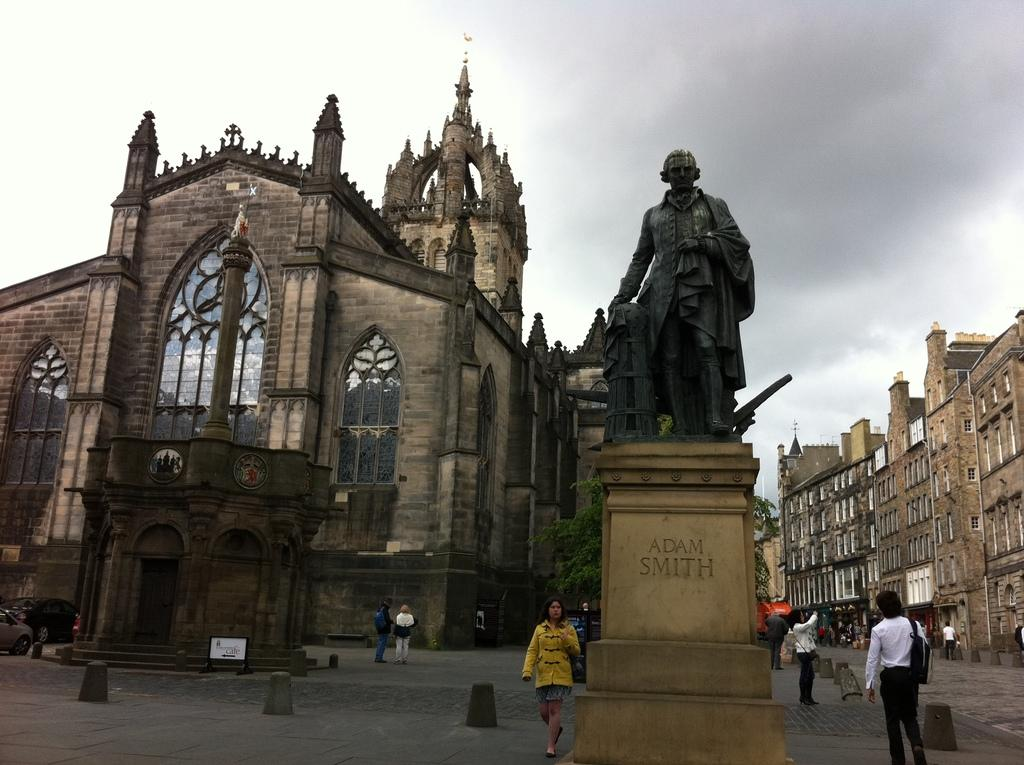What is the main subject in the foreground of the image? There is a sculpture on the road in the foreground of the image. What are the people in the image doing? There are persons moving on the road in the image. What can be seen in the background of the image? There are buildings visible in the image. What is the condition of the sky in the image? The sky contains clouds in the image. How many giants can be seen walking alongside the persons in the image? There are no giants present in the image; only the sculpture, persons, buildings, and clouds can be seen. What type of addition problem can be solved using the numbers of buildings and persons in the image? There is no information provided about the number of buildings or persons in the image, so it is not possible to create an addition problem based on this information. 